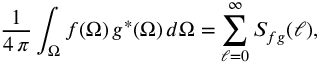<formula> <loc_0><loc_0><loc_500><loc_500>{ \frac { 1 } { 4 \, \pi } } \int _ { \Omega } f ( \Omega ) \, g ^ { \ast } ( \Omega ) \, d \Omega = \sum _ { \ell = 0 } ^ { \infty } S _ { f g } ( \ell ) ,</formula> 